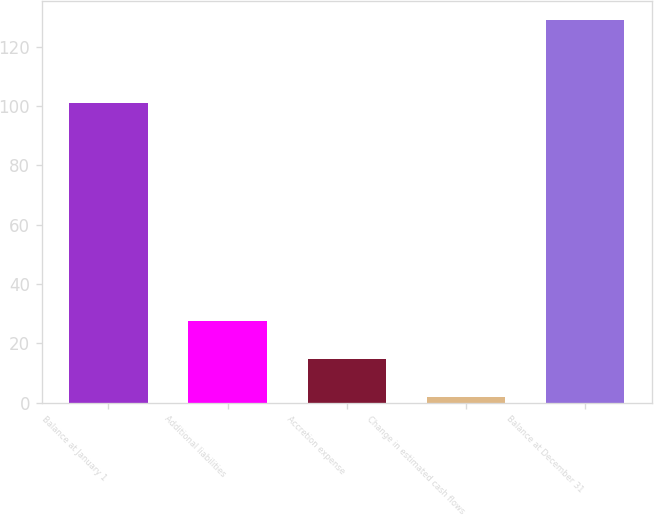Convert chart. <chart><loc_0><loc_0><loc_500><loc_500><bar_chart><fcel>Balance at January 1<fcel>Additional liabilities<fcel>Accretion expense<fcel>Change in estimated cash flows<fcel>Balance at December 31<nl><fcel>101<fcel>27.4<fcel>14.7<fcel>2<fcel>129<nl></chart> 